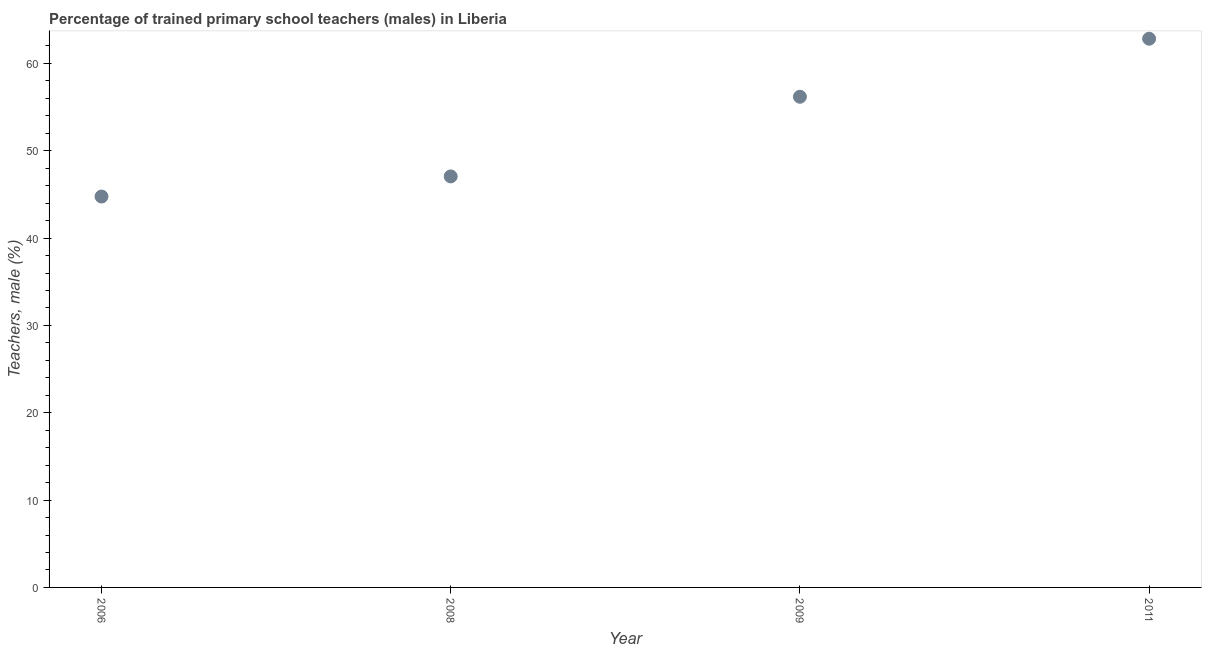What is the percentage of trained male teachers in 2009?
Your answer should be compact. 56.18. Across all years, what is the maximum percentage of trained male teachers?
Offer a terse response. 62.83. Across all years, what is the minimum percentage of trained male teachers?
Your answer should be compact. 44.76. What is the sum of the percentage of trained male teachers?
Offer a very short reply. 210.82. What is the difference between the percentage of trained male teachers in 2008 and 2011?
Your response must be concise. -15.76. What is the average percentage of trained male teachers per year?
Ensure brevity in your answer.  52.71. What is the median percentage of trained male teachers?
Your answer should be compact. 51.62. In how many years, is the percentage of trained male teachers greater than 6 %?
Provide a short and direct response. 4. What is the ratio of the percentage of trained male teachers in 2008 to that in 2011?
Your answer should be very brief. 0.75. Is the percentage of trained male teachers in 2006 less than that in 2008?
Provide a succinct answer. Yes. What is the difference between the highest and the second highest percentage of trained male teachers?
Your response must be concise. 6.64. What is the difference between the highest and the lowest percentage of trained male teachers?
Keep it short and to the point. 18.07. In how many years, is the percentage of trained male teachers greater than the average percentage of trained male teachers taken over all years?
Provide a short and direct response. 2. How many years are there in the graph?
Keep it short and to the point. 4. Are the values on the major ticks of Y-axis written in scientific E-notation?
Offer a very short reply. No. Does the graph contain grids?
Offer a very short reply. No. What is the title of the graph?
Ensure brevity in your answer.  Percentage of trained primary school teachers (males) in Liberia. What is the label or title of the Y-axis?
Provide a succinct answer. Teachers, male (%). What is the Teachers, male (%) in 2006?
Your answer should be compact. 44.76. What is the Teachers, male (%) in 2008?
Ensure brevity in your answer.  47.06. What is the Teachers, male (%) in 2009?
Ensure brevity in your answer.  56.18. What is the Teachers, male (%) in 2011?
Offer a very short reply. 62.83. What is the difference between the Teachers, male (%) in 2006 and 2008?
Make the answer very short. -2.31. What is the difference between the Teachers, male (%) in 2006 and 2009?
Provide a succinct answer. -11.43. What is the difference between the Teachers, male (%) in 2006 and 2011?
Keep it short and to the point. -18.07. What is the difference between the Teachers, male (%) in 2008 and 2009?
Provide a succinct answer. -9.12. What is the difference between the Teachers, male (%) in 2008 and 2011?
Offer a very short reply. -15.76. What is the difference between the Teachers, male (%) in 2009 and 2011?
Give a very brief answer. -6.64. What is the ratio of the Teachers, male (%) in 2006 to that in 2008?
Your answer should be compact. 0.95. What is the ratio of the Teachers, male (%) in 2006 to that in 2009?
Give a very brief answer. 0.8. What is the ratio of the Teachers, male (%) in 2006 to that in 2011?
Provide a succinct answer. 0.71. What is the ratio of the Teachers, male (%) in 2008 to that in 2009?
Ensure brevity in your answer.  0.84. What is the ratio of the Teachers, male (%) in 2008 to that in 2011?
Keep it short and to the point. 0.75. What is the ratio of the Teachers, male (%) in 2009 to that in 2011?
Keep it short and to the point. 0.89. 